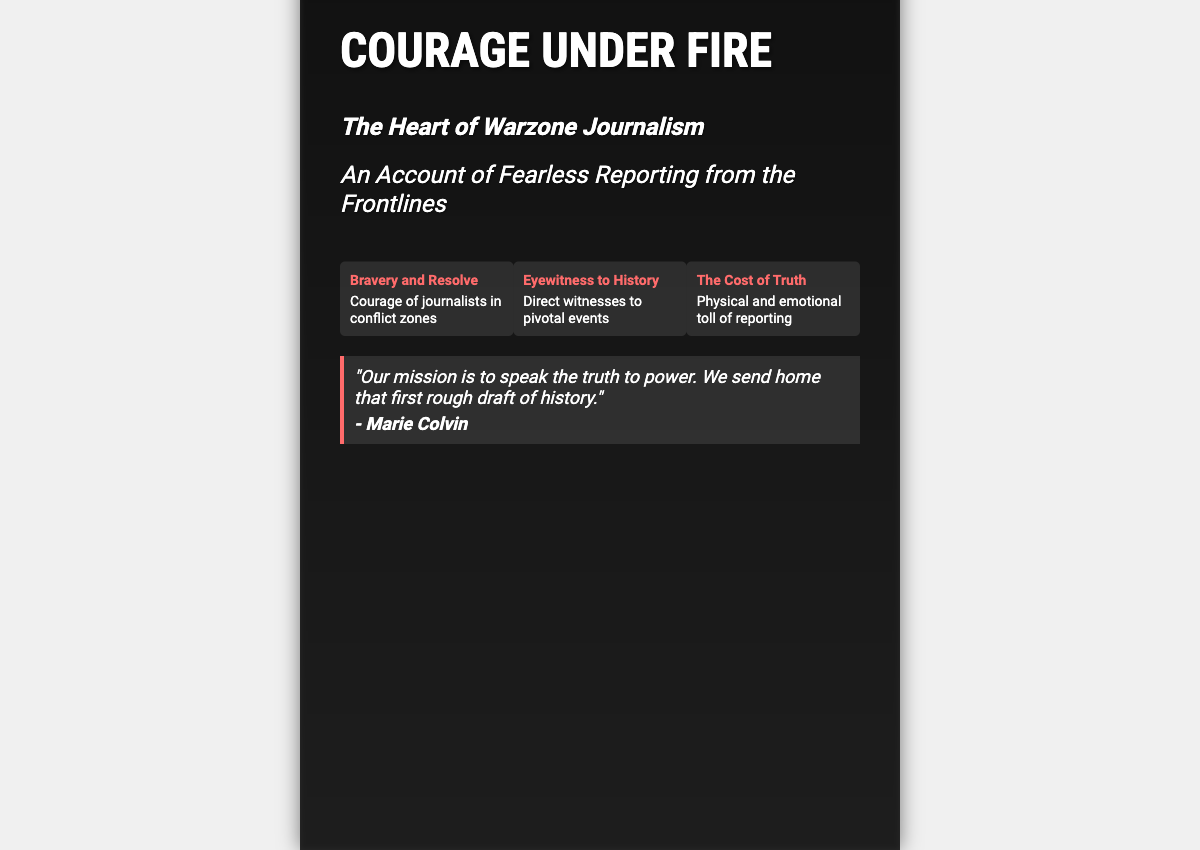what is the title of the book? The title of the book is prominently displayed at the top of the cover.
Answer: Courage Under Fire who is the author of the book? The author's name is mentioned at the bottom of the cover.
Answer: Alex Turner what is the subtitle of the book? The subtitle of the book provides additional context about its content.
Answer: The Heart of Warzone Journalism how many themes are displayed on the cover? The cover highlights three distinct themes related to the book.
Answer: 3 who quoted the phrase on the cover? The quote is attributed to a notable journalist mentioned at the bottom of the quote section.
Answer: Marie Colvin what is the main theme related to journalists in conflict zones? This theme captures a core aspect of the book regarding the courage of journalists.
Answer: Bravery and Resolve what physical elements are present in the background of the cover? The background of the cover features visuals indicative of a conflict zone, enhancing the book's theme.
Answer: Military vehicles and smoke what mission do warzone journalists aim to accomplish? The quoted mission emphasizes the role of journalists in documenting history.
Answer: Speak the truth to power 